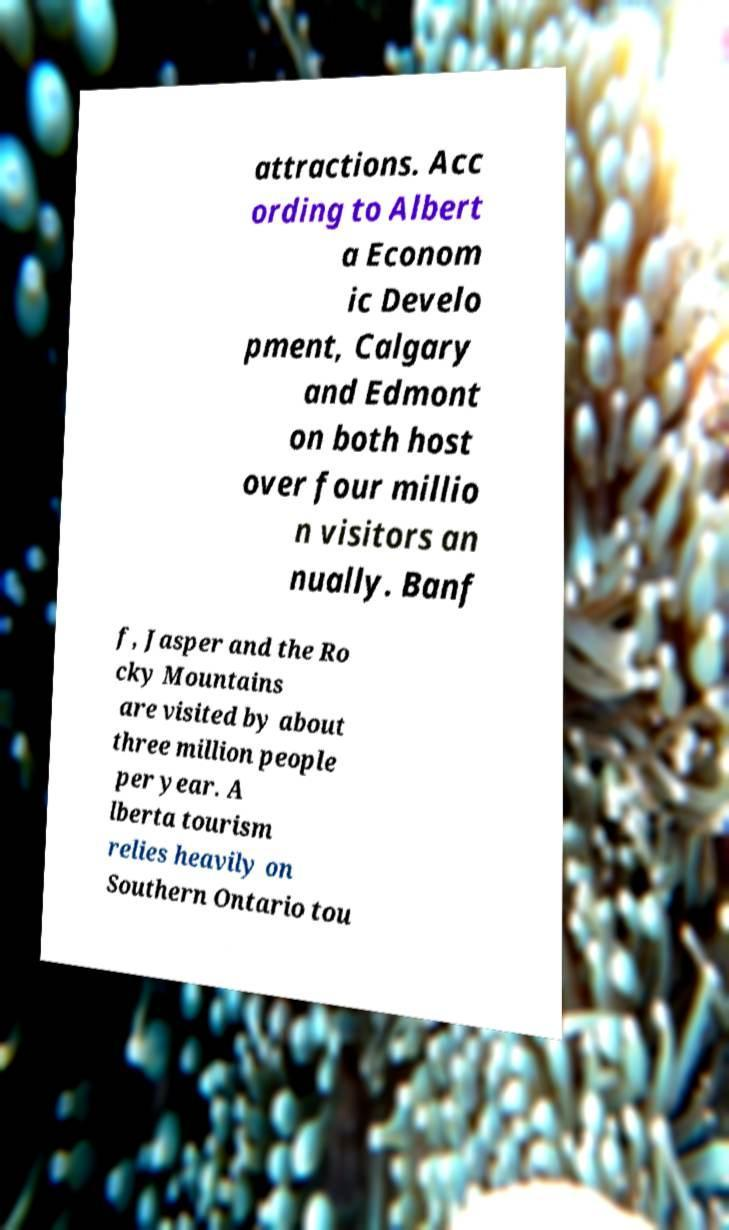Can you read and provide the text displayed in the image?This photo seems to have some interesting text. Can you extract and type it out for me? attractions. Acc ording to Albert a Econom ic Develo pment, Calgary and Edmont on both host over four millio n visitors an nually. Banf f, Jasper and the Ro cky Mountains are visited by about three million people per year. A lberta tourism relies heavily on Southern Ontario tou 